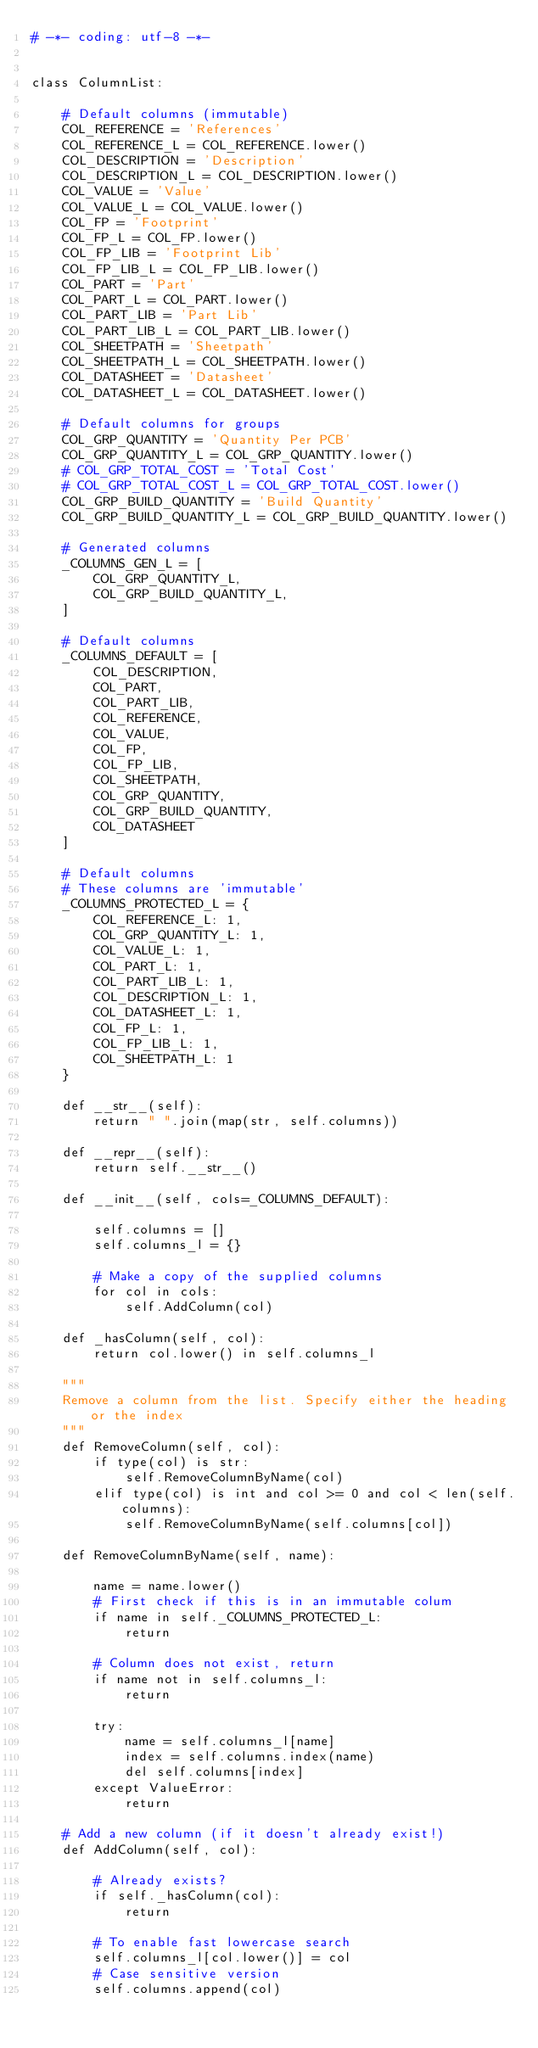<code> <loc_0><loc_0><loc_500><loc_500><_Python_># -*- coding: utf-8 -*-


class ColumnList:

    # Default columns (immutable)
    COL_REFERENCE = 'References'
    COL_REFERENCE_L = COL_REFERENCE.lower()
    COL_DESCRIPTION = 'Description'
    COL_DESCRIPTION_L = COL_DESCRIPTION.lower()
    COL_VALUE = 'Value'
    COL_VALUE_L = COL_VALUE.lower()
    COL_FP = 'Footprint'
    COL_FP_L = COL_FP.lower()
    COL_FP_LIB = 'Footprint Lib'
    COL_FP_LIB_L = COL_FP_LIB.lower()
    COL_PART = 'Part'
    COL_PART_L = COL_PART.lower()
    COL_PART_LIB = 'Part Lib'
    COL_PART_LIB_L = COL_PART_LIB.lower()
    COL_SHEETPATH = 'Sheetpath'
    COL_SHEETPATH_L = COL_SHEETPATH.lower()
    COL_DATASHEET = 'Datasheet'
    COL_DATASHEET_L = COL_DATASHEET.lower()

    # Default columns for groups
    COL_GRP_QUANTITY = 'Quantity Per PCB'
    COL_GRP_QUANTITY_L = COL_GRP_QUANTITY.lower()
    # COL_GRP_TOTAL_COST = 'Total Cost'
    # COL_GRP_TOTAL_COST_L = COL_GRP_TOTAL_COST.lower()
    COL_GRP_BUILD_QUANTITY = 'Build Quantity'
    COL_GRP_BUILD_QUANTITY_L = COL_GRP_BUILD_QUANTITY.lower()

    # Generated columns
    _COLUMNS_GEN_L = [
        COL_GRP_QUANTITY_L,
        COL_GRP_BUILD_QUANTITY_L,
    ]

    # Default columns
    _COLUMNS_DEFAULT = [
        COL_DESCRIPTION,
        COL_PART,
        COL_PART_LIB,
        COL_REFERENCE,
        COL_VALUE,
        COL_FP,
        COL_FP_LIB,
        COL_SHEETPATH,
        COL_GRP_QUANTITY,
        COL_GRP_BUILD_QUANTITY,
        COL_DATASHEET
    ]

    # Default columns
    # These columns are 'immutable'
    _COLUMNS_PROTECTED_L = {
        COL_REFERENCE_L: 1,
        COL_GRP_QUANTITY_L: 1,
        COL_VALUE_L: 1,
        COL_PART_L: 1,
        COL_PART_LIB_L: 1,
        COL_DESCRIPTION_L: 1,
        COL_DATASHEET_L: 1,
        COL_FP_L: 1,
        COL_FP_LIB_L: 1,
        COL_SHEETPATH_L: 1
    }

    def __str__(self):
        return " ".join(map(str, self.columns))

    def __repr__(self):
        return self.__str__()

    def __init__(self, cols=_COLUMNS_DEFAULT):

        self.columns = []
        self.columns_l = {}

        # Make a copy of the supplied columns
        for col in cols:
            self.AddColumn(col)

    def _hasColumn(self, col):
        return col.lower() in self.columns_l

    """
    Remove a column from the list. Specify either the heading or the index
    """
    def RemoveColumn(self, col):
        if type(col) is str:
            self.RemoveColumnByName(col)
        elif type(col) is int and col >= 0 and col < len(self.columns):
            self.RemoveColumnByName(self.columns[col])

    def RemoveColumnByName(self, name):

        name = name.lower()
        # First check if this is in an immutable colum
        if name in self._COLUMNS_PROTECTED_L:
            return

        # Column does not exist, return
        if name not in self.columns_l:
            return

        try:
            name = self.columns_l[name]
            index = self.columns.index(name)
            del self.columns[index]
        except ValueError:
            return

    # Add a new column (if it doesn't already exist!)
    def AddColumn(self, col):

        # Already exists?
        if self._hasColumn(col):
            return

        # To enable fast lowercase search
        self.columns_l[col.lower()] = col
        # Case sensitive version
        self.columns.append(col)
</code> 